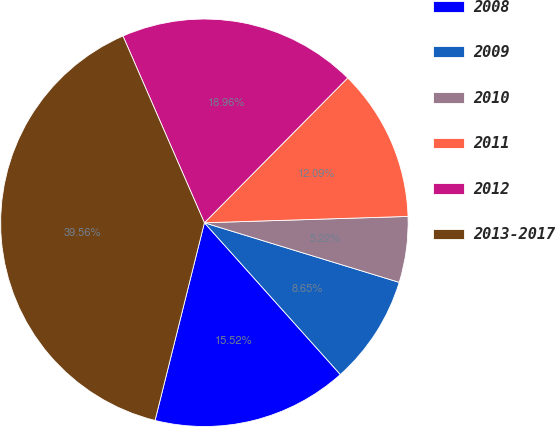Convert chart to OTSL. <chart><loc_0><loc_0><loc_500><loc_500><pie_chart><fcel>2008<fcel>2009<fcel>2010<fcel>2011<fcel>2012<fcel>2013-2017<nl><fcel>15.52%<fcel>8.65%<fcel>5.22%<fcel>12.09%<fcel>18.96%<fcel>39.56%<nl></chart> 